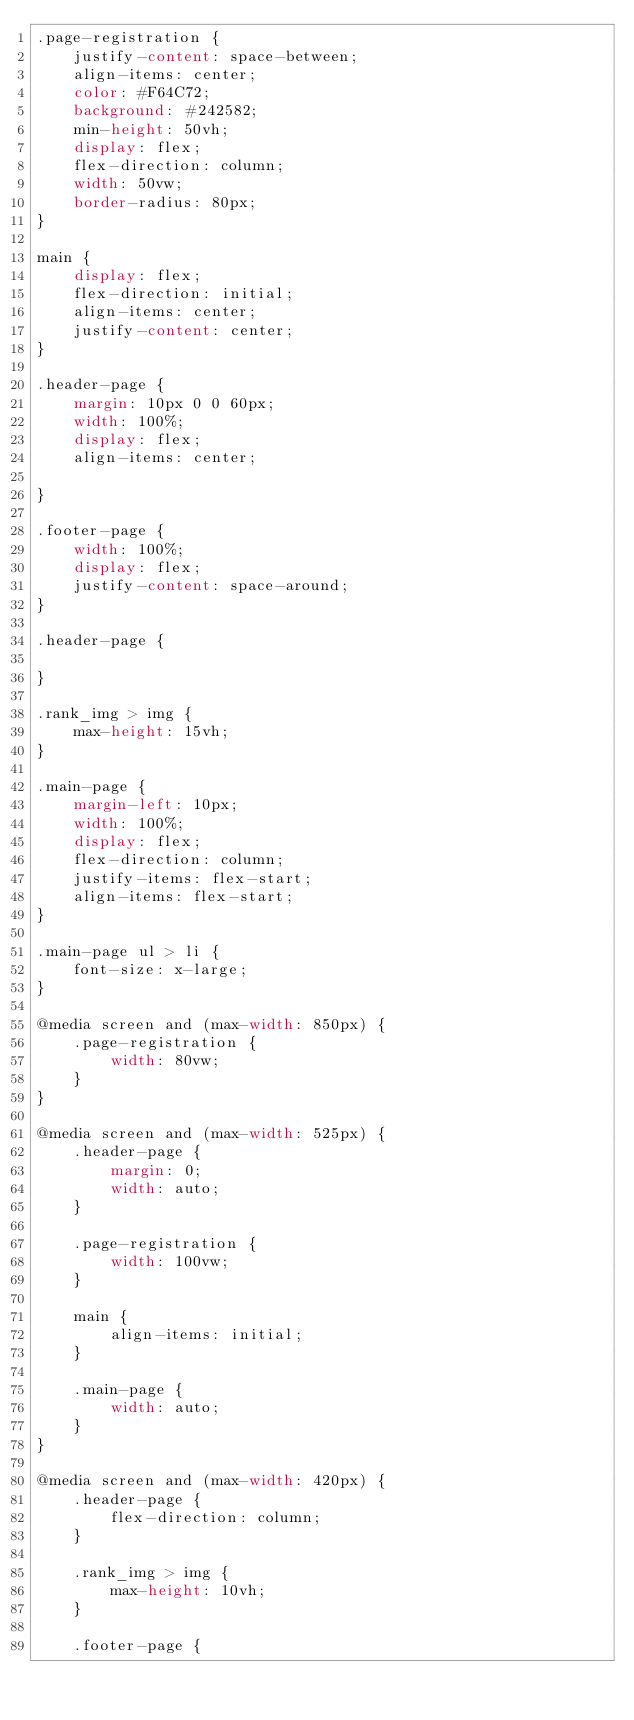<code> <loc_0><loc_0><loc_500><loc_500><_CSS_>.page-registration {
    justify-content: space-between;
    align-items: center;
    color: #F64C72;
    background: #242582;
    min-height: 50vh;
    display: flex;
    flex-direction: column;
    width: 50vw;
    border-radius: 80px;
}

main {
    display: flex;
    flex-direction: initial;
    align-items: center;
    justify-content: center;
}

.header-page {
    margin: 10px 0 0 60px;
    width: 100%;
    display: flex;
    align-items: center;

}

.footer-page {
    width: 100%;
    display: flex;
    justify-content: space-around;
}

.header-page {

}

.rank_img > img {
    max-height: 15vh;
}

.main-page {
    margin-left: 10px;
    width: 100%;
    display: flex;
    flex-direction: column;
    justify-items: flex-start;
    align-items: flex-start;
}

.main-page ul > li {
    font-size: x-large;
}

@media screen and (max-width: 850px) {
    .page-registration {
        width: 80vw;
    }
}

@media screen and (max-width: 525px) {
    .header-page {
        margin: 0;
        width: auto;
    }

    .page-registration {
        width: 100vw;
    }

    main {
        align-items: initial;
    }

    .main-page {
        width: auto;
    }
}

@media screen and (max-width: 420px) {
    .header-page {
        flex-direction: column;
    }

    .rank_img > img {
        max-height: 10vh;
    }

    .footer-page {</code> 